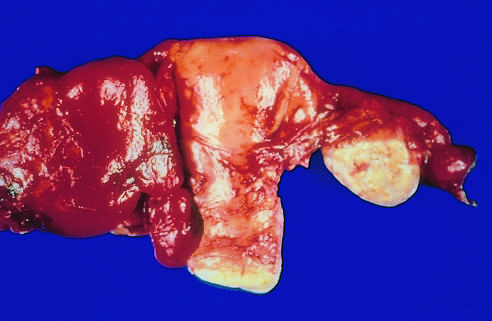s the tube adherent to the adjacent ovary on the other side?
Answer the question using a single word or phrase. Yes 